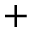Convert formula to latex. <formula><loc_0><loc_0><loc_500><loc_500>^ { + }</formula> 